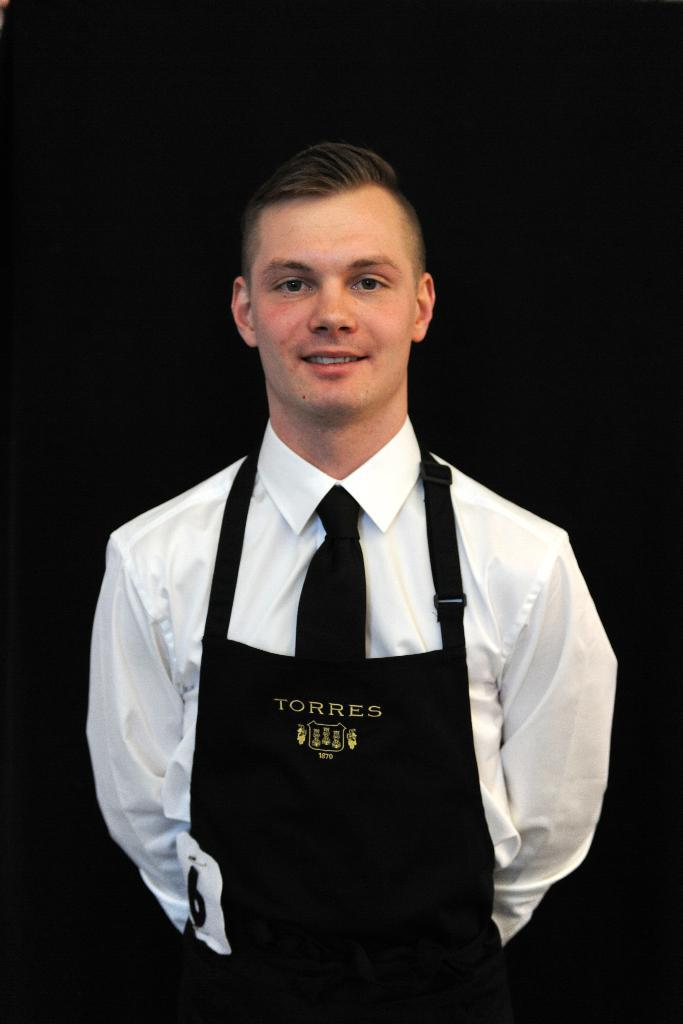What is the main subject of the image? There is a person in the image. Where is the person located in the image? The person is standing in the middle of the image. What is the person's facial expression? The person is smiling. What is the person wearing? The person is wearing a cloth. What type of notebook is the person holding in the image? There is no notebook present in the image. How many pockets can be seen on the person's clothing? The provided facts do not mention any pockets on the person's clothing. 